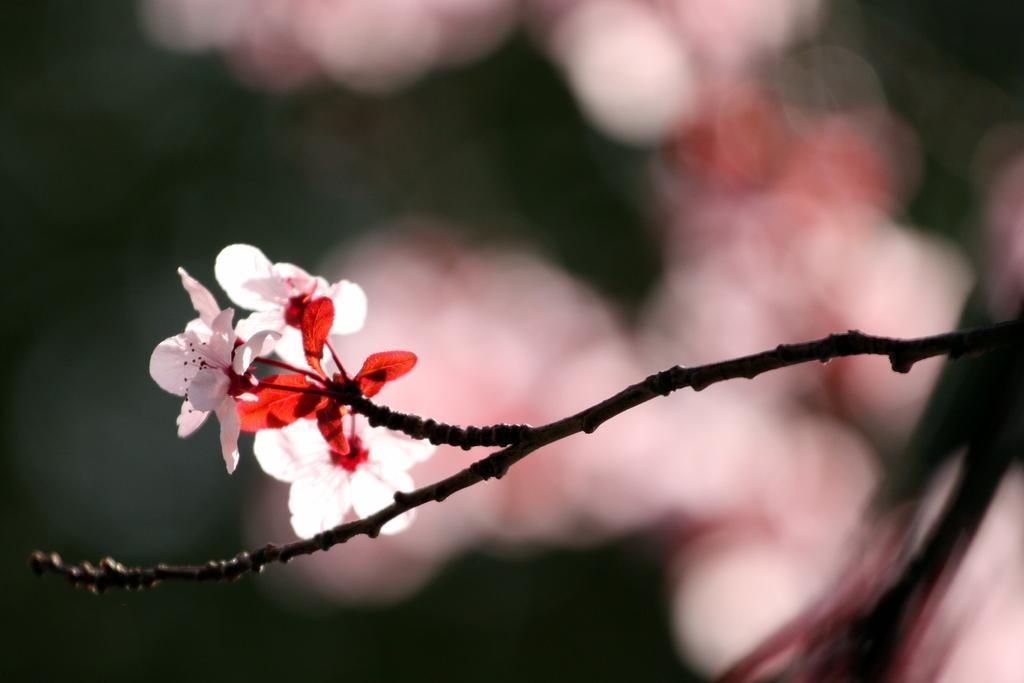Please provide a concise description of this image. In this image there are flowers on the branch of a tree. 